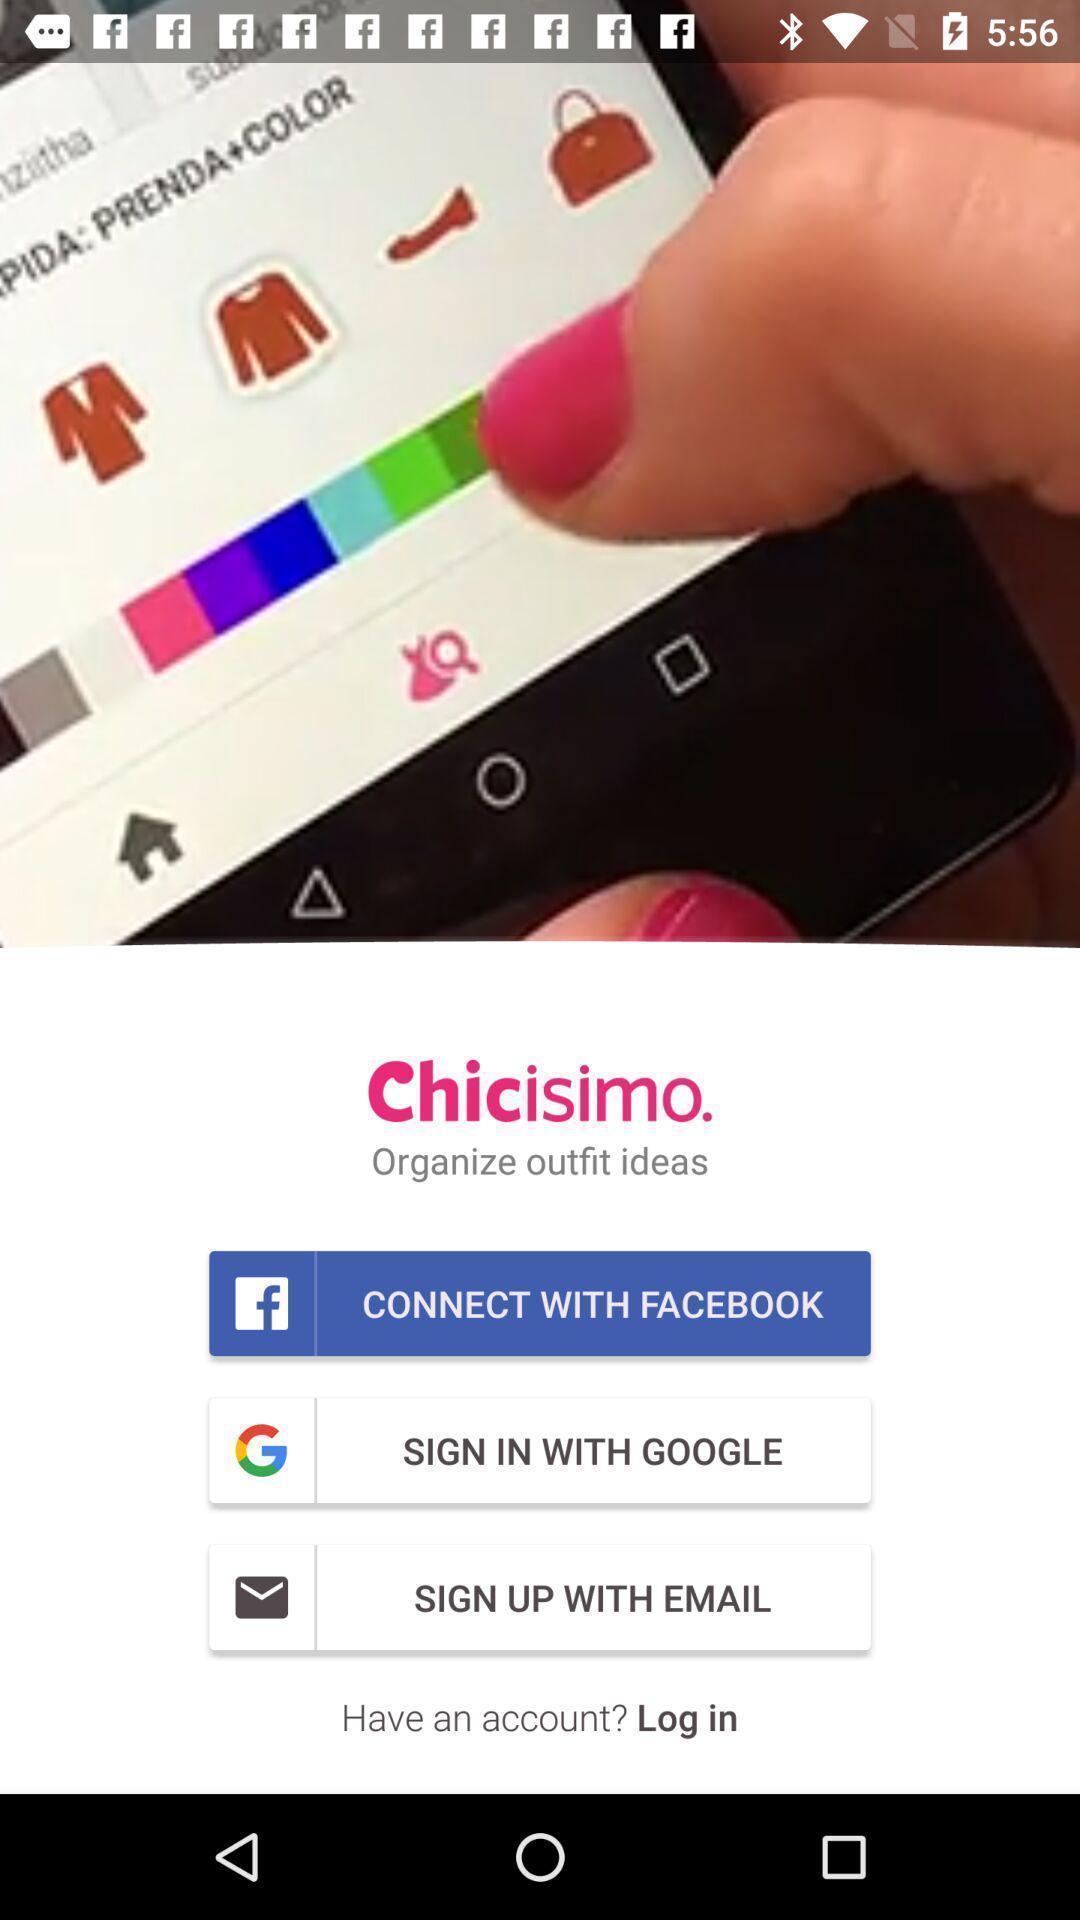Describe the content in this image. Sign in page of different social media apps. 